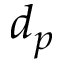Convert formula to latex. <formula><loc_0><loc_0><loc_500><loc_500>d _ { p }</formula> 